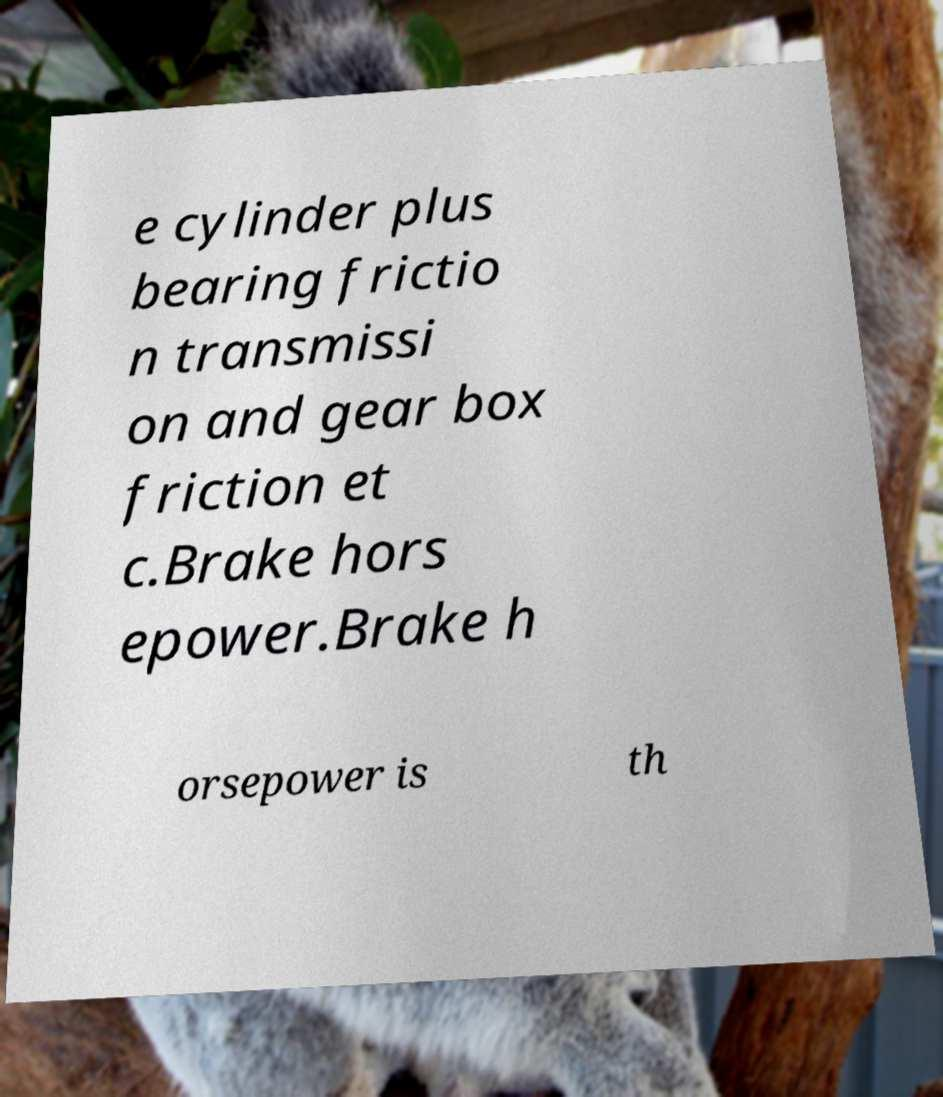Could you assist in decoding the text presented in this image and type it out clearly? e cylinder plus bearing frictio n transmissi on and gear box friction et c.Brake hors epower.Brake h orsepower is th 